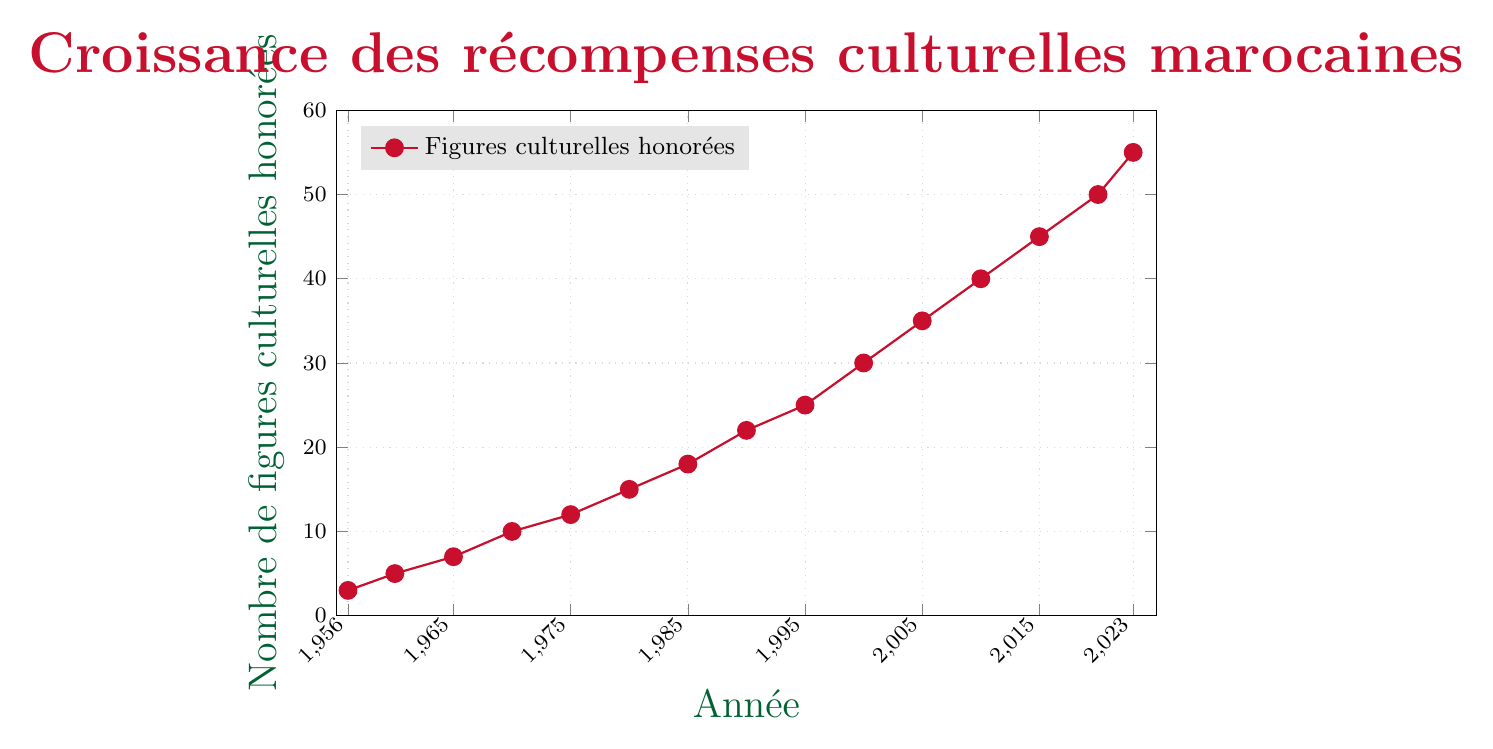Which year had the highest number of Moroccan cultural figures honored? The figure shows that the highest number of Moroccan cultural figures honored is in the year 2023 with a count of 55.
Answer: 2023 What was the number of Moroccan cultural figures honored in 1970? The year 1970 is marked with a data point indicating 10 Moroccan cultural figures were honored.
Answer: 10 Between which two consecutive years was the largest increase in the number of Moroccan cultural figures honored? By examining the data points, the largest increase occurred between 1995 and 2000, with an increase from 25 to 30, which is 5.
Answer: 1995 and 2000 What is the average number of Moroccan cultural figures honored between 1956 and 2023? Summing all the given values: 3 + 5 + 7 + 10 + 12 + 15 + 18+ 22+25+30+35+40+45+50+55 = 372, then dividing that by the number of years (15): 372/15 = 24.8.
Answer: 24.8 How did the number of honored cultural figures change from 1980 to 1985? The number increased from 15 in 1980 to 18 in 1985. The difference is 3.
Answer: Increased by 3 Which two years show an equal number of Moroccan cultural figures honored? The graph shows the figures for each year, yes, after checking, no two years have the same number of honored figures.
Answer: No years with equal figures What is the trend in the number of Moroccan cultural figures honored from 1956 to 2023? The figure demonstrates a general increasing trend in the number honored over the years, starting from 3 in 1956 and rising to 55 by 2023.
Answer: Increasing trend How many more cultural figures were honored in 2023 than in 1956? The number honored in 2023 is 55 and in 1956 is 3. The difference is 55 - 3 = 52.
Answer: 52 In which period did the number of cultural figures honored grow the least? Between 1970 and 1975, the count grew from 10 to 12, which is an increase of 2, the least increment among other periods.
Answer: 1970 to 1975 What is the total number of Moroccan cultural figures honored from 1960 to 1970? Summing the data points for 1960, 1965, and 1970: 5 + 7 + 10 = 22.
Answer: 22 